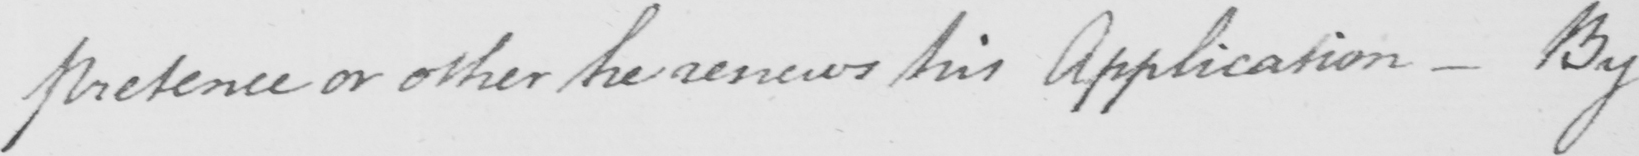Please provide the text content of this handwritten line. pretence or other he renews his Application  _  By 